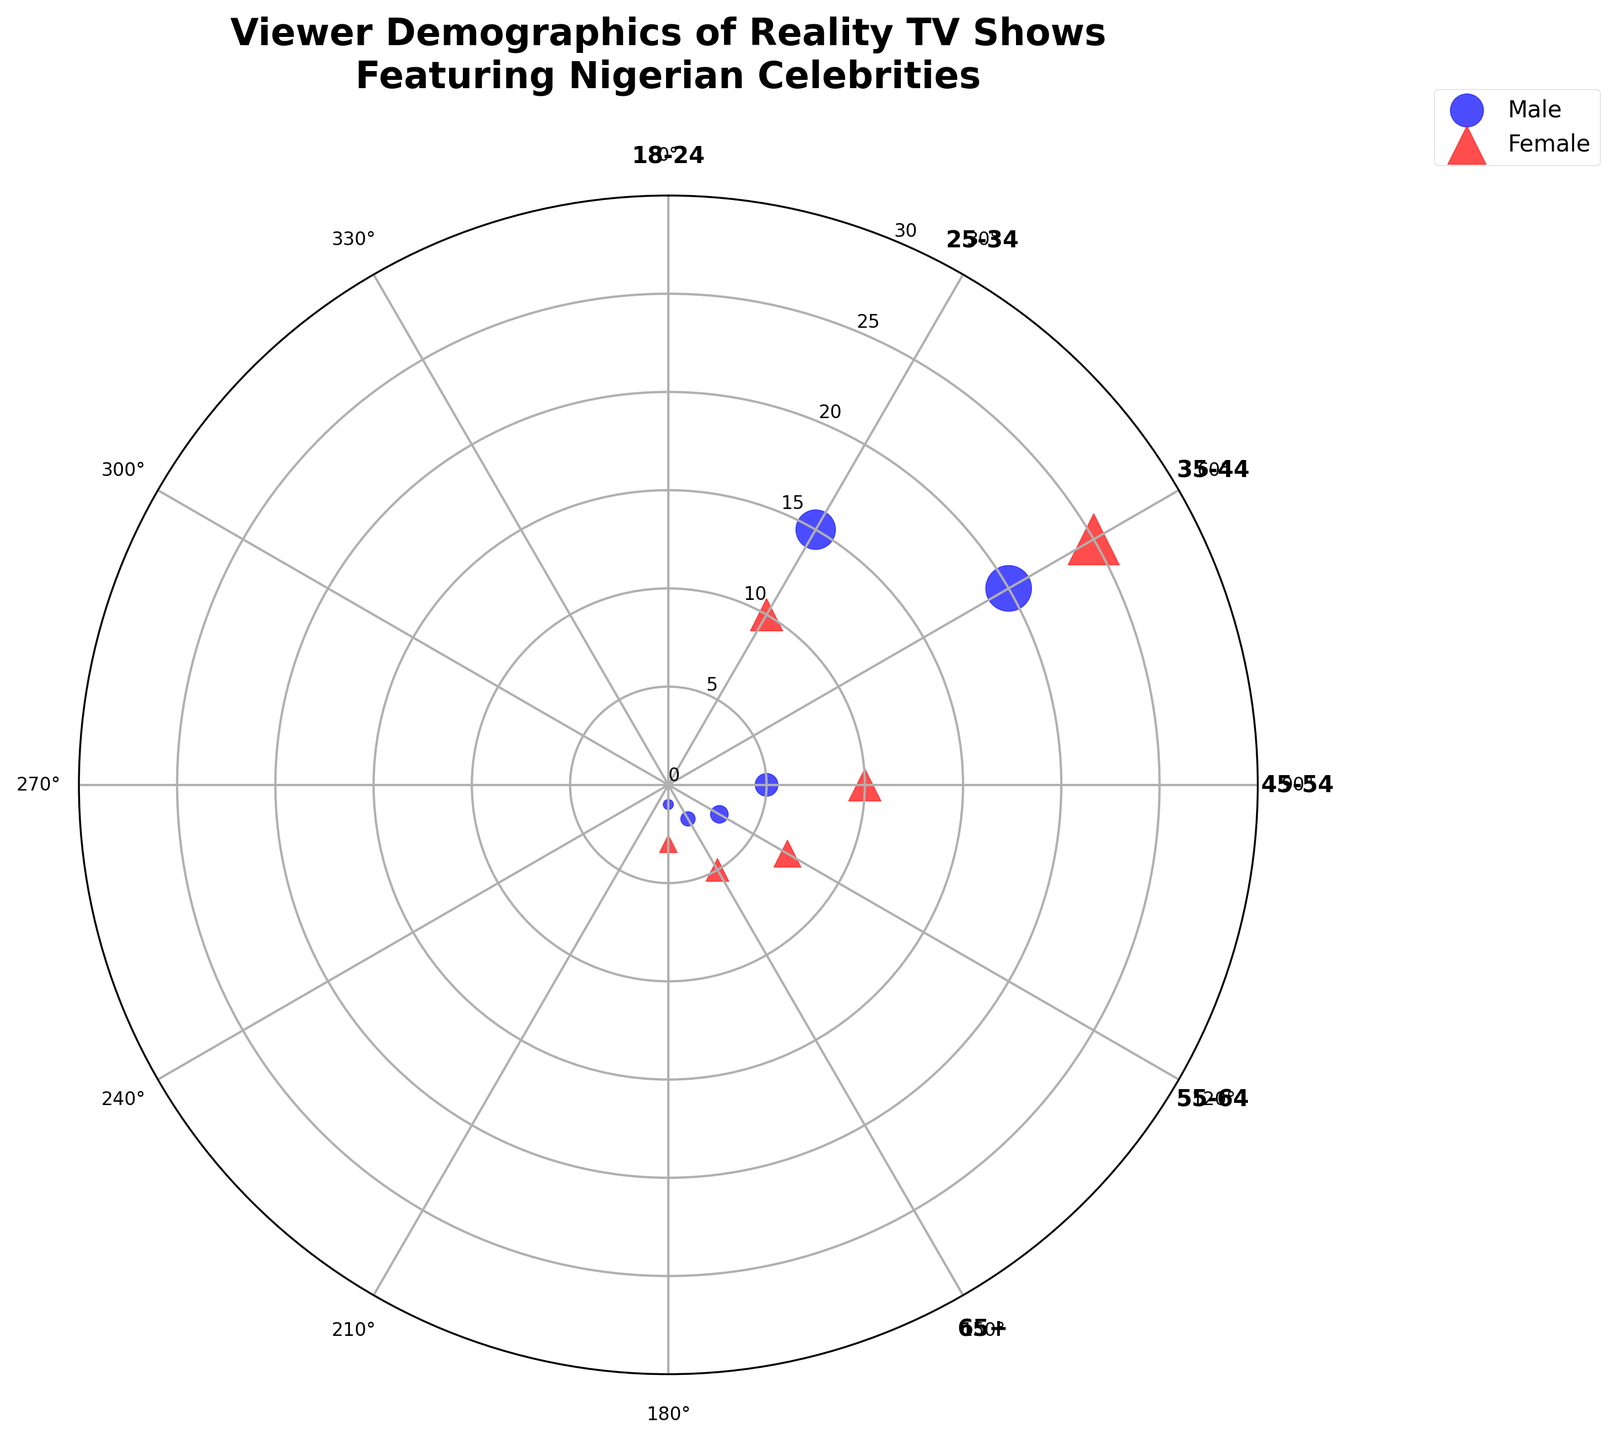How many age groups are represented in the chart? Count the number of unique age groups labeled along the angular axis of the plot. The groups are labeled as 18-24, 25-34, 35-44, 45-54, 55-64, and 65+.
Answer: 6 Which gender has a larger radius for the 25-34 age group? Locate the data points for the 25-34 age group and compare the radius values. The male radius is 20, and the female radius is 25.
Answer: Female What is the total number of male viewers in all age groups? Sum the radius values of all male data points: 15 (18-24) + 20 (25-34) + 5 (35-44) + 3 (45-54) + 2 (55-64) + 1 (65+). 15 + 20 + 5 + 3 + 2 + 1 = 46
Answer: 46 What's the difference in viewer numbers between females aged 18-24 and 25-34? Subtract the radius of the 18-24 female group from the 25-34 female group: 25 - 10.
Answer: 15 What age group has the smallest total viewership and how many is it? Sum the radii of male and female points for each age group. The smallest sum is for the 65+ group: 1 (male) + 3 (female) = 4.
Answer: 65+, 4 Which gender has more viewers aged 35-44 and by how much? Compare the radius values for 35-44 age group; males have 5, and females have 10. The difference is: 10 - 5.
Answer: Female, 5 How many data points have a radius value of 10? Identify and count the data points with radius value 10; they are Female_18-24 and Female_35-44.
Answer: 2 What age group has the highest male viewership and what is the value? Look for the highest radius in male data points; it is 25-34 with radius 20.
Answer: 25-34, 20 Are there more viewers aged 45-54 or 55-64? Sum the radii for both age groups: 45-54 (3+7=10), 55-64 (2+5=7). Compare the sums.
Answer: 45-54 